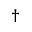<formula> <loc_0><loc_0><loc_500><loc_500>^ { \dagger }</formula> 